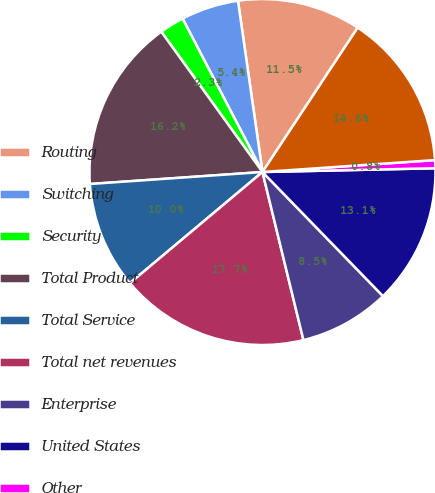Convert chart to OTSL. <chart><loc_0><loc_0><loc_500><loc_500><pie_chart><fcel>Routing<fcel>Switching<fcel>Security<fcel>Total Product<fcel>Total Service<fcel>Total net revenues<fcel>Enterprise<fcel>United States<fcel>Other<fcel>Total Americas<nl><fcel>11.54%<fcel>5.38%<fcel>2.3%<fcel>16.16%<fcel>10.0%<fcel>17.7%<fcel>8.46%<fcel>13.08%<fcel>0.75%<fcel>14.62%<nl></chart> 